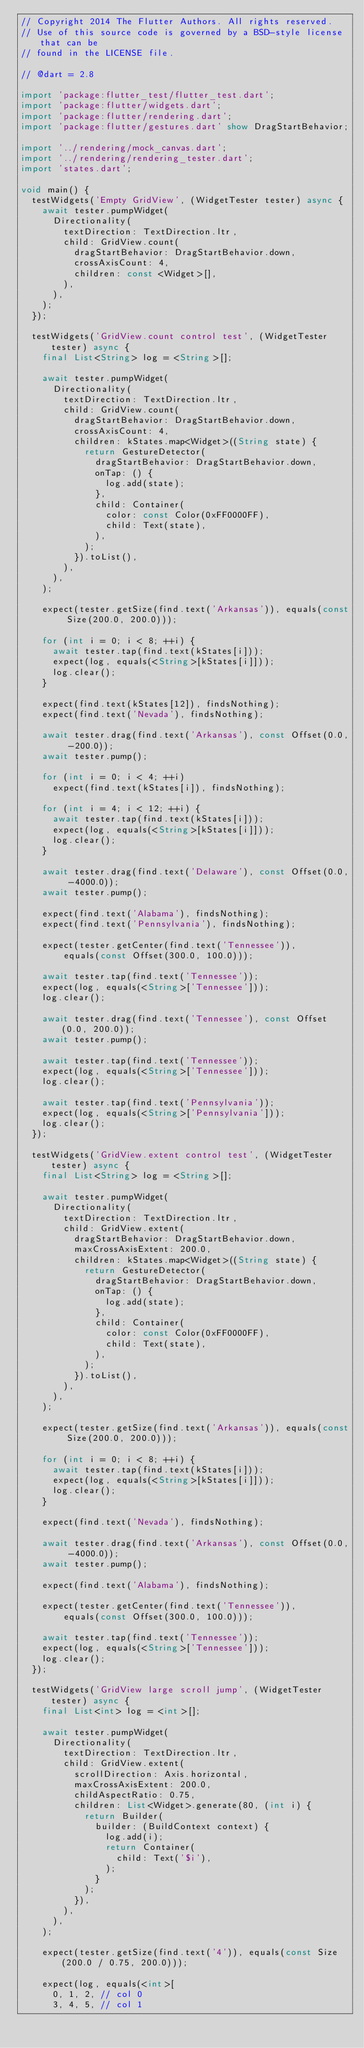Convert code to text. <code><loc_0><loc_0><loc_500><loc_500><_Dart_>// Copyright 2014 The Flutter Authors. All rights reserved.
// Use of this source code is governed by a BSD-style license that can be
// found in the LICENSE file.

// @dart = 2.8

import 'package:flutter_test/flutter_test.dart';
import 'package:flutter/widgets.dart';
import 'package:flutter/rendering.dart';
import 'package:flutter/gestures.dart' show DragStartBehavior;

import '../rendering/mock_canvas.dart';
import '../rendering/rendering_tester.dart';
import 'states.dart';

void main() {
  testWidgets('Empty GridView', (WidgetTester tester) async {
    await tester.pumpWidget(
      Directionality(
        textDirection: TextDirection.ltr,
        child: GridView.count(
          dragStartBehavior: DragStartBehavior.down,
          crossAxisCount: 4,
          children: const <Widget>[],
        ),
      ),
    );
  });

  testWidgets('GridView.count control test', (WidgetTester tester) async {
    final List<String> log = <String>[];

    await tester.pumpWidget(
      Directionality(
        textDirection: TextDirection.ltr,
        child: GridView.count(
          dragStartBehavior: DragStartBehavior.down,
          crossAxisCount: 4,
          children: kStates.map<Widget>((String state) {
            return GestureDetector(
              dragStartBehavior: DragStartBehavior.down,
              onTap: () {
                log.add(state);
              },
              child: Container(
                color: const Color(0xFF0000FF),
                child: Text(state),
              ),
            );
          }).toList(),
        ),
      ),
    );

    expect(tester.getSize(find.text('Arkansas')), equals(const Size(200.0, 200.0)));

    for (int i = 0; i < 8; ++i) {
      await tester.tap(find.text(kStates[i]));
      expect(log, equals(<String>[kStates[i]]));
      log.clear();
    }

    expect(find.text(kStates[12]), findsNothing);
    expect(find.text('Nevada'), findsNothing);

    await tester.drag(find.text('Arkansas'), const Offset(0.0, -200.0));
    await tester.pump();

    for (int i = 0; i < 4; ++i)
      expect(find.text(kStates[i]), findsNothing);

    for (int i = 4; i < 12; ++i) {
      await tester.tap(find.text(kStates[i]));
      expect(log, equals(<String>[kStates[i]]));
      log.clear();
    }

    await tester.drag(find.text('Delaware'), const Offset(0.0, -4000.0));
    await tester.pump();

    expect(find.text('Alabama'), findsNothing);
    expect(find.text('Pennsylvania'), findsNothing);

    expect(tester.getCenter(find.text('Tennessee')),
        equals(const Offset(300.0, 100.0)));

    await tester.tap(find.text('Tennessee'));
    expect(log, equals(<String>['Tennessee']));
    log.clear();

    await tester.drag(find.text('Tennessee'), const Offset(0.0, 200.0));
    await tester.pump();

    await tester.tap(find.text('Tennessee'));
    expect(log, equals(<String>['Tennessee']));
    log.clear();

    await tester.tap(find.text('Pennsylvania'));
    expect(log, equals(<String>['Pennsylvania']));
    log.clear();
  });

  testWidgets('GridView.extent control test', (WidgetTester tester) async {
    final List<String> log = <String>[];

    await tester.pumpWidget(
      Directionality(
        textDirection: TextDirection.ltr,
        child: GridView.extent(
          dragStartBehavior: DragStartBehavior.down,
          maxCrossAxisExtent: 200.0,
          children: kStates.map<Widget>((String state) {
            return GestureDetector(
              dragStartBehavior: DragStartBehavior.down,
              onTap: () {
                log.add(state);
              },
              child: Container(
                color: const Color(0xFF0000FF),
                child: Text(state),
              ),
            );
          }).toList(),
        ),
      ),
    );

    expect(tester.getSize(find.text('Arkansas')), equals(const Size(200.0, 200.0)));

    for (int i = 0; i < 8; ++i) {
      await tester.tap(find.text(kStates[i]));
      expect(log, equals(<String>[kStates[i]]));
      log.clear();
    }

    expect(find.text('Nevada'), findsNothing);

    await tester.drag(find.text('Arkansas'), const Offset(0.0, -4000.0));
    await tester.pump();

    expect(find.text('Alabama'), findsNothing);

    expect(tester.getCenter(find.text('Tennessee')),
        equals(const Offset(300.0, 100.0)));

    await tester.tap(find.text('Tennessee'));
    expect(log, equals(<String>['Tennessee']));
    log.clear();
  });

  testWidgets('GridView large scroll jump', (WidgetTester tester) async {
    final List<int> log = <int>[];

    await tester.pumpWidget(
      Directionality(
        textDirection: TextDirection.ltr,
        child: GridView.extent(
          scrollDirection: Axis.horizontal,
          maxCrossAxisExtent: 200.0,
          childAspectRatio: 0.75,
          children: List<Widget>.generate(80, (int i) {
            return Builder(
              builder: (BuildContext context) {
                log.add(i);
                return Container(
                  child: Text('$i'),
                );
              }
            );
          }),
        ),
      ),
    );

    expect(tester.getSize(find.text('4')), equals(const Size(200.0 / 0.75, 200.0)));

    expect(log, equals(<int>[
      0, 1, 2, // col 0
      3, 4, 5, // col 1</code> 